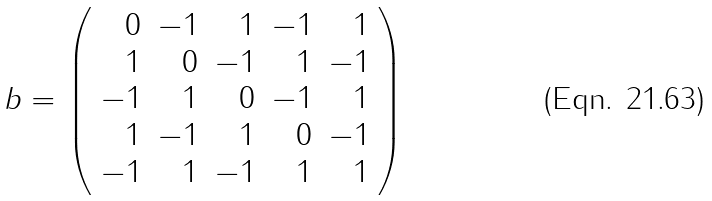Convert formula to latex. <formula><loc_0><loc_0><loc_500><loc_500>b = \left ( \begin{array} { r r r r r } 0 & - 1 & 1 & - 1 & 1 \\ 1 & 0 & - 1 & 1 & - 1 \\ - 1 & 1 & 0 & - 1 & 1 \\ 1 & - 1 & 1 & 0 & - 1 \\ - 1 & 1 & - 1 & 1 & 1 \\ \end{array} \right )</formula> 